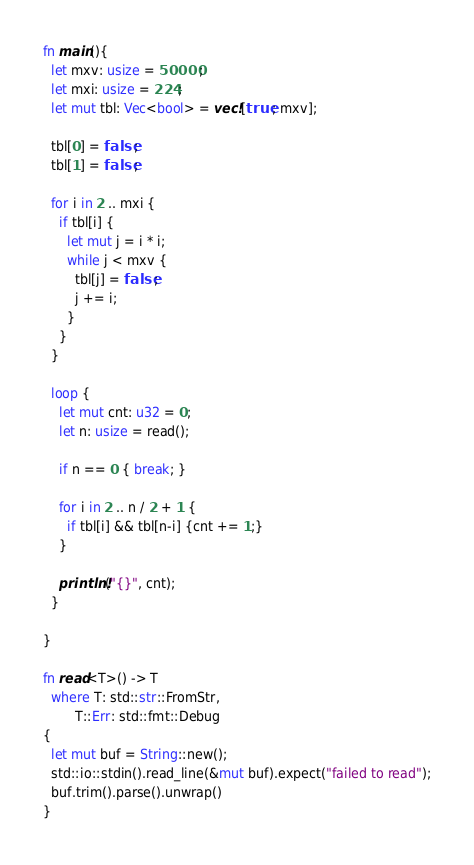Convert code to text. <code><loc_0><loc_0><loc_500><loc_500><_Rust_>fn main(){
  let mxv: usize = 50000;
  let mxi: usize = 224;
  let mut tbl: Vec<bool> = vec![true; mxv];

  tbl[0] = false;
  tbl[1] = false;

  for i in 2 .. mxi {
    if tbl[i] {
      let mut j = i * i;
      while j < mxv {
        tbl[j] = false;
        j += i;
      }
    }
  }

  loop {
    let mut cnt: u32 = 0;
    let n: usize = read();

    if n == 0 { break; }

    for i in 2 .. n / 2 + 1 {
      if tbl[i] && tbl[n-i] {cnt += 1;}
    }

    println!("{}", cnt);
  }
  
}

fn read<T>() -> T
  where T: std::str::FromStr,
        T::Err: std::fmt::Debug
{
  let mut buf = String::new();
  std::io::stdin().read_line(&mut buf).expect("failed to read");
  buf.trim().parse().unwrap()
}

</code> 